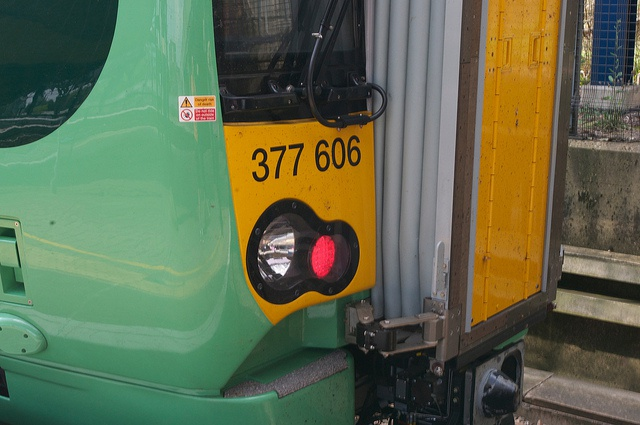Describe the objects in this image and their specific colors. I can see a train in black, teal, turquoise, and gray tones in this image. 